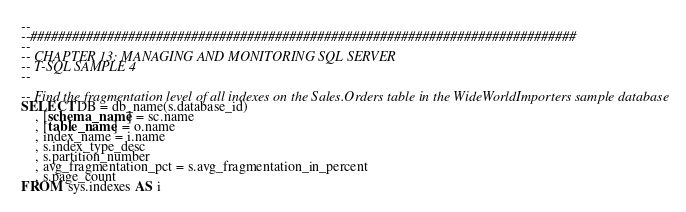Convert code to text. <code><loc_0><loc_0><loc_500><loc_500><_SQL_>--
--##############################################################################
--
-- CHAPTER 13: MANAGING AND MONITORING SQL SERVER
-- T-SQL SAMPLE 4
--

-- Find the fragmentation level of all indexes on the Sales.Orders table in the WideWorldImporters sample database
SELECT DB = db_name(s.database_id)
	, [schema_name] = sc.name
	, [table_name] = o.name
	, index_name = i.name
	, s.index_type_desc
	, s.partition_number
	, avg_fragmentation_pct = s.avg_fragmentation_in_percent
	, s.page_count
FROM  sys.indexes AS i </code> 